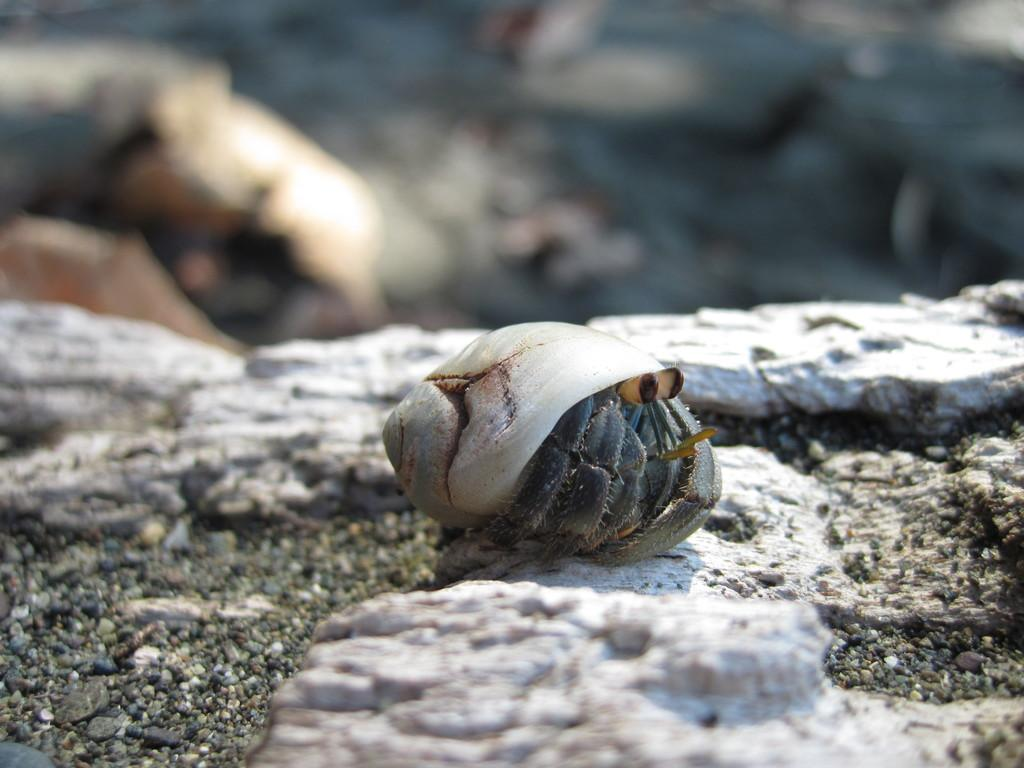What is the main object in the image? There is a conch in the image. Where is the conch located? The conch is on a stone. Can you describe the background of the image? The background of the image is blurred. What type of wire can be seen connecting the rabbit and the zebra in the image? There is no wire, rabbit, or zebra present in the image. 